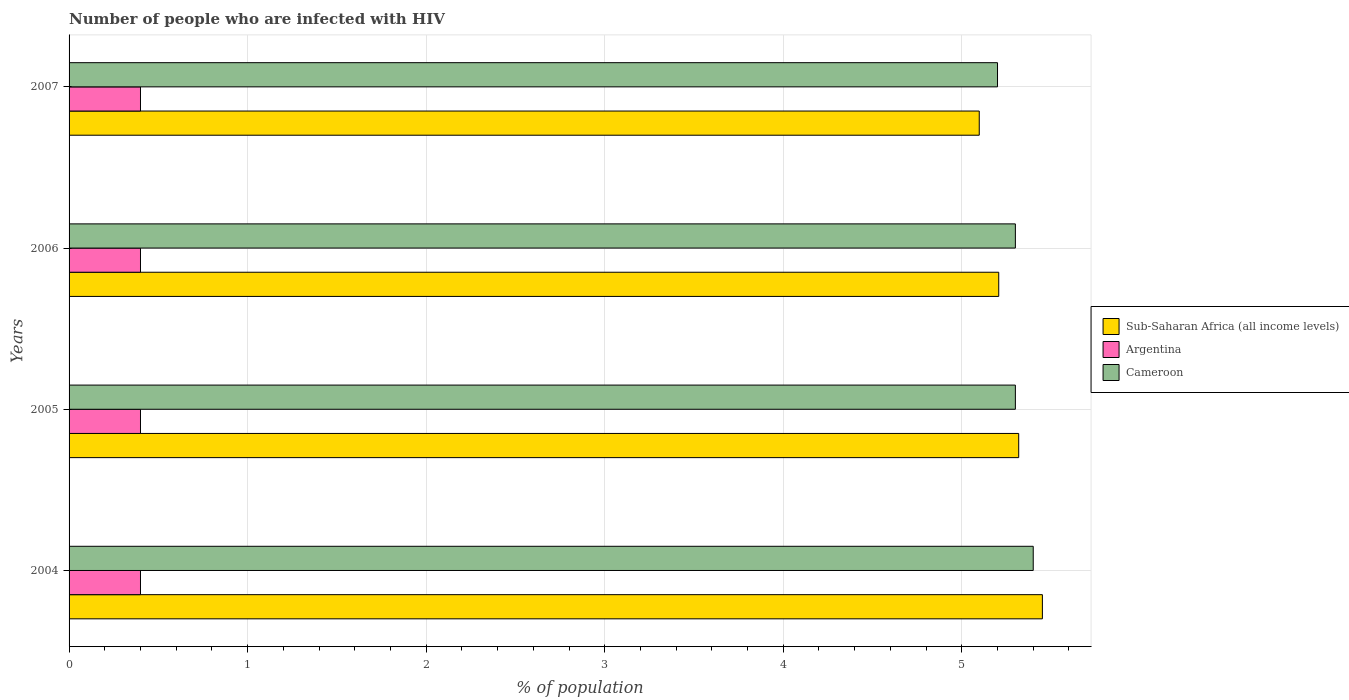Are the number of bars per tick equal to the number of legend labels?
Give a very brief answer. Yes. Are the number of bars on each tick of the Y-axis equal?
Provide a short and direct response. Yes. How many bars are there on the 3rd tick from the bottom?
Offer a very short reply. 3. What is the label of the 4th group of bars from the top?
Your answer should be compact. 2004. What is the percentage of HIV infected population in in Argentina in 2004?
Your answer should be compact. 0.4. What is the total percentage of HIV infected population in in Cameroon in the graph?
Offer a very short reply. 21.2. What is the difference between the percentage of HIV infected population in in Argentina in 2005 and that in 2006?
Give a very brief answer. 0. What is the difference between the percentage of HIV infected population in in Cameroon in 2004 and the percentage of HIV infected population in in Sub-Saharan Africa (all income levels) in 2005?
Keep it short and to the point. 0.08. What is the average percentage of HIV infected population in in Sub-Saharan Africa (all income levels) per year?
Your answer should be compact. 5.27. In the year 2007, what is the difference between the percentage of HIV infected population in in Sub-Saharan Africa (all income levels) and percentage of HIV infected population in in Cameroon?
Ensure brevity in your answer.  -0.1. What is the ratio of the percentage of HIV infected population in in Sub-Saharan Africa (all income levels) in 2005 to that in 2007?
Offer a terse response. 1.04. Is the percentage of HIV infected population in in Cameroon in 2004 less than that in 2005?
Your answer should be very brief. No. What is the difference between the highest and the second highest percentage of HIV infected population in in Argentina?
Your answer should be very brief. 0. What is the difference between the highest and the lowest percentage of HIV infected population in in Argentina?
Ensure brevity in your answer.  0. In how many years, is the percentage of HIV infected population in in Sub-Saharan Africa (all income levels) greater than the average percentage of HIV infected population in in Sub-Saharan Africa (all income levels) taken over all years?
Give a very brief answer. 2. What does the 1st bar from the top in 2006 represents?
Your answer should be very brief. Cameroon. What does the 1st bar from the bottom in 2007 represents?
Ensure brevity in your answer.  Sub-Saharan Africa (all income levels). How many bars are there?
Provide a short and direct response. 12. Are all the bars in the graph horizontal?
Offer a terse response. Yes. How many years are there in the graph?
Provide a short and direct response. 4. Are the values on the major ticks of X-axis written in scientific E-notation?
Give a very brief answer. No. Where does the legend appear in the graph?
Ensure brevity in your answer.  Center right. What is the title of the graph?
Keep it short and to the point. Number of people who are infected with HIV. What is the label or title of the X-axis?
Offer a very short reply. % of population. What is the label or title of the Y-axis?
Give a very brief answer. Years. What is the % of population of Sub-Saharan Africa (all income levels) in 2004?
Make the answer very short. 5.45. What is the % of population in Cameroon in 2004?
Keep it short and to the point. 5.4. What is the % of population in Sub-Saharan Africa (all income levels) in 2005?
Offer a terse response. 5.32. What is the % of population in Sub-Saharan Africa (all income levels) in 2006?
Ensure brevity in your answer.  5.21. What is the % of population in Sub-Saharan Africa (all income levels) in 2007?
Provide a succinct answer. 5.1. What is the % of population of Cameroon in 2007?
Keep it short and to the point. 5.2. Across all years, what is the maximum % of population in Sub-Saharan Africa (all income levels)?
Offer a terse response. 5.45. Across all years, what is the maximum % of population of Cameroon?
Your answer should be compact. 5.4. Across all years, what is the minimum % of population in Sub-Saharan Africa (all income levels)?
Offer a terse response. 5.1. Across all years, what is the minimum % of population of Argentina?
Make the answer very short. 0.4. Across all years, what is the minimum % of population in Cameroon?
Offer a very short reply. 5.2. What is the total % of population in Sub-Saharan Africa (all income levels) in the graph?
Offer a very short reply. 21.07. What is the total % of population of Cameroon in the graph?
Ensure brevity in your answer.  21.2. What is the difference between the % of population in Sub-Saharan Africa (all income levels) in 2004 and that in 2005?
Offer a very short reply. 0.13. What is the difference between the % of population of Sub-Saharan Africa (all income levels) in 2004 and that in 2006?
Ensure brevity in your answer.  0.24. What is the difference between the % of population in Argentina in 2004 and that in 2006?
Your response must be concise. 0. What is the difference between the % of population in Sub-Saharan Africa (all income levels) in 2004 and that in 2007?
Give a very brief answer. 0.35. What is the difference between the % of population in Sub-Saharan Africa (all income levels) in 2005 and that in 2006?
Make the answer very short. 0.11. What is the difference between the % of population of Argentina in 2005 and that in 2006?
Offer a terse response. 0. What is the difference between the % of population in Cameroon in 2005 and that in 2006?
Your answer should be very brief. 0. What is the difference between the % of population in Sub-Saharan Africa (all income levels) in 2005 and that in 2007?
Your answer should be compact. 0.22. What is the difference between the % of population of Sub-Saharan Africa (all income levels) in 2006 and that in 2007?
Keep it short and to the point. 0.11. What is the difference between the % of population of Cameroon in 2006 and that in 2007?
Make the answer very short. 0.1. What is the difference between the % of population of Sub-Saharan Africa (all income levels) in 2004 and the % of population of Argentina in 2005?
Your answer should be compact. 5.05. What is the difference between the % of population in Sub-Saharan Africa (all income levels) in 2004 and the % of population in Cameroon in 2005?
Your answer should be compact. 0.15. What is the difference between the % of population in Sub-Saharan Africa (all income levels) in 2004 and the % of population in Argentina in 2006?
Provide a succinct answer. 5.05. What is the difference between the % of population in Sub-Saharan Africa (all income levels) in 2004 and the % of population in Cameroon in 2006?
Your answer should be compact. 0.15. What is the difference between the % of population in Argentina in 2004 and the % of population in Cameroon in 2006?
Your answer should be very brief. -4.9. What is the difference between the % of population of Sub-Saharan Africa (all income levels) in 2004 and the % of population of Argentina in 2007?
Your answer should be very brief. 5.05. What is the difference between the % of population of Sub-Saharan Africa (all income levels) in 2004 and the % of population of Cameroon in 2007?
Make the answer very short. 0.25. What is the difference between the % of population of Argentina in 2004 and the % of population of Cameroon in 2007?
Keep it short and to the point. -4.8. What is the difference between the % of population of Sub-Saharan Africa (all income levels) in 2005 and the % of population of Argentina in 2006?
Your response must be concise. 4.92. What is the difference between the % of population of Sub-Saharan Africa (all income levels) in 2005 and the % of population of Cameroon in 2006?
Your response must be concise. 0.02. What is the difference between the % of population in Argentina in 2005 and the % of population in Cameroon in 2006?
Provide a succinct answer. -4.9. What is the difference between the % of population of Sub-Saharan Africa (all income levels) in 2005 and the % of population of Argentina in 2007?
Give a very brief answer. 4.92. What is the difference between the % of population of Sub-Saharan Africa (all income levels) in 2005 and the % of population of Cameroon in 2007?
Make the answer very short. 0.12. What is the difference between the % of population in Argentina in 2005 and the % of population in Cameroon in 2007?
Your answer should be very brief. -4.8. What is the difference between the % of population in Sub-Saharan Africa (all income levels) in 2006 and the % of population in Argentina in 2007?
Keep it short and to the point. 4.81. What is the difference between the % of population of Sub-Saharan Africa (all income levels) in 2006 and the % of population of Cameroon in 2007?
Offer a terse response. 0.01. What is the average % of population in Sub-Saharan Africa (all income levels) per year?
Provide a short and direct response. 5.27. What is the average % of population of Argentina per year?
Your answer should be compact. 0.4. What is the average % of population of Cameroon per year?
Ensure brevity in your answer.  5.3. In the year 2004, what is the difference between the % of population in Sub-Saharan Africa (all income levels) and % of population in Argentina?
Offer a terse response. 5.05. In the year 2004, what is the difference between the % of population of Sub-Saharan Africa (all income levels) and % of population of Cameroon?
Provide a succinct answer. 0.05. In the year 2004, what is the difference between the % of population of Argentina and % of population of Cameroon?
Give a very brief answer. -5. In the year 2005, what is the difference between the % of population of Sub-Saharan Africa (all income levels) and % of population of Argentina?
Offer a terse response. 4.92. In the year 2005, what is the difference between the % of population in Sub-Saharan Africa (all income levels) and % of population in Cameroon?
Give a very brief answer. 0.02. In the year 2006, what is the difference between the % of population in Sub-Saharan Africa (all income levels) and % of population in Argentina?
Your answer should be compact. 4.81. In the year 2006, what is the difference between the % of population of Sub-Saharan Africa (all income levels) and % of population of Cameroon?
Your answer should be compact. -0.09. In the year 2006, what is the difference between the % of population of Argentina and % of population of Cameroon?
Give a very brief answer. -4.9. In the year 2007, what is the difference between the % of population in Sub-Saharan Africa (all income levels) and % of population in Argentina?
Offer a terse response. 4.7. In the year 2007, what is the difference between the % of population of Sub-Saharan Africa (all income levels) and % of population of Cameroon?
Make the answer very short. -0.1. In the year 2007, what is the difference between the % of population of Argentina and % of population of Cameroon?
Your response must be concise. -4.8. What is the ratio of the % of population in Sub-Saharan Africa (all income levels) in 2004 to that in 2005?
Provide a short and direct response. 1.02. What is the ratio of the % of population in Argentina in 2004 to that in 2005?
Ensure brevity in your answer.  1. What is the ratio of the % of population in Cameroon in 2004 to that in 2005?
Your answer should be compact. 1.02. What is the ratio of the % of population in Sub-Saharan Africa (all income levels) in 2004 to that in 2006?
Your response must be concise. 1.05. What is the ratio of the % of population of Argentina in 2004 to that in 2006?
Ensure brevity in your answer.  1. What is the ratio of the % of population in Cameroon in 2004 to that in 2006?
Your response must be concise. 1.02. What is the ratio of the % of population of Sub-Saharan Africa (all income levels) in 2004 to that in 2007?
Keep it short and to the point. 1.07. What is the ratio of the % of population of Argentina in 2004 to that in 2007?
Provide a short and direct response. 1. What is the ratio of the % of population in Cameroon in 2004 to that in 2007?
Offer a very short reply. 1.04. What is the ratio of the % of population of Sub-Saharan Africa (all income levels) in 2005 to that in 2006?
Offer a terse response. 1.02. What is the ratio of the % of population in Argentina in 2005 to that in 2006?
Your answer should be compact. 1. What is the ratio of the % of population in Sub-Saharan Africa (all income levels) in 2005 to that in 2007?
Your answer should be compact. 1.04. What is the ratio of the % of population in Cameroon in 2005 to that in 2007?
Keep it short and to the point. 1.02. What is the ratio of the % of population of Sub-Saharan Africa (all income levels) in 2006 to that in 2007?
Your response must be concise. 1.02. What is the ratio of the % of population of Cameroon in 2006 to that in 2007?
Your response must be concise. 1.02. What is the difference between the highest and the second highest % of population of Sub-Saharan Africa (all income levels)?
Offer a very short reply. 0.13. What is the difference between the highest and the second highest % of population in Argentina?
Keep it short and to the point. 0. What is the difference between the highest and the second highest % of population in Cameroon?
Your answer should be compact. 0.1. What is the difference between the highest and the lowest % of population of Sub-Saharan Africa (all income levels)?
Your answer should be very brief. 0.35. What is the difference between the highest and the lowest % of population in Cameroon?
Provide a succinct answer. 0.2. 